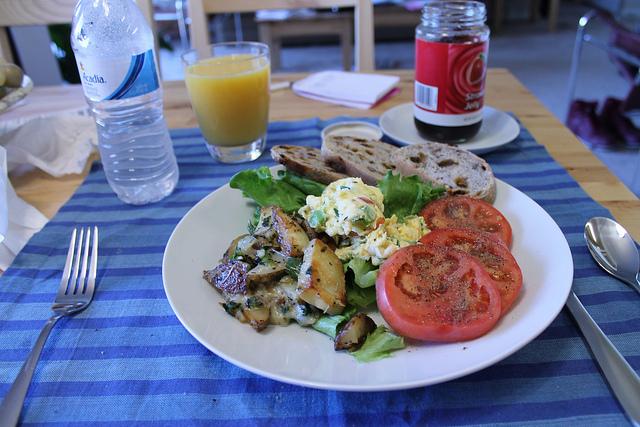What tells you this is a breakfast dish?
Write a very short answer. Orange juice. Is there a bottle of water?
Keep it brief. Yes. What is the red food on the plate?
Concise answer only. Tomato. 